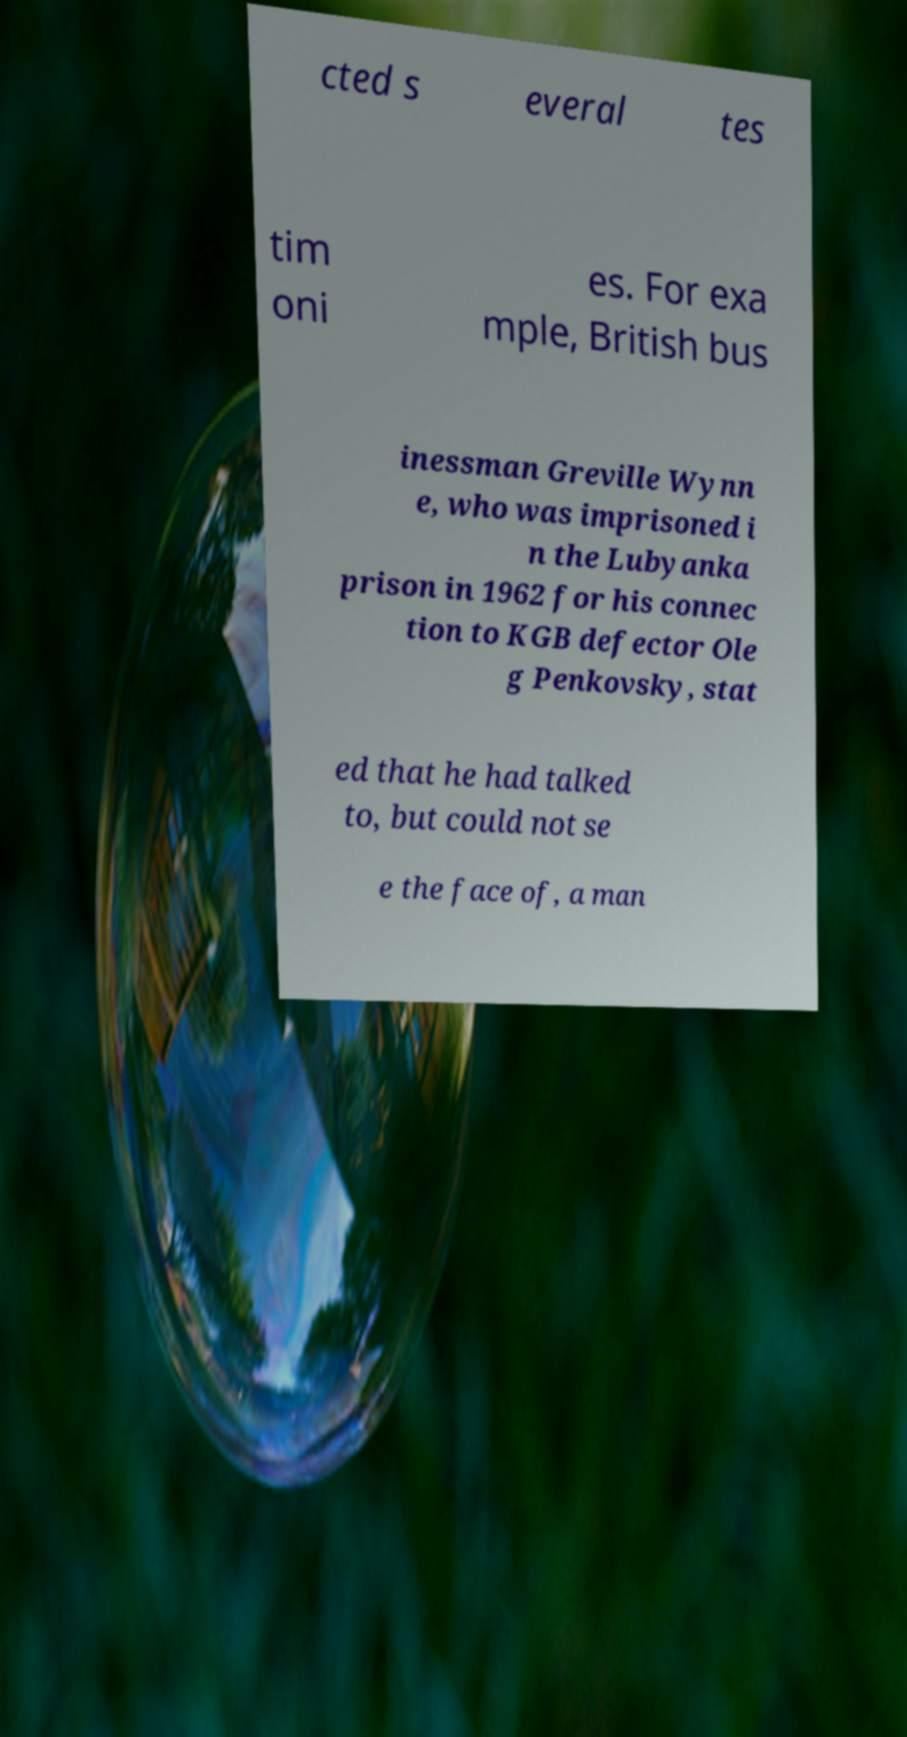For documentation purposes, I need the text within this image transcribed. Could you provide that? cted s everal tes tim oni es. For exa mple, British bus inessman Greville Wynn e, who was imprisoned i n the Lubyanka prison in 1962 for his connec tion to KGB defector Ole g Penkovsky, stat ed that he had talked to, but could not se e the face of, a man 